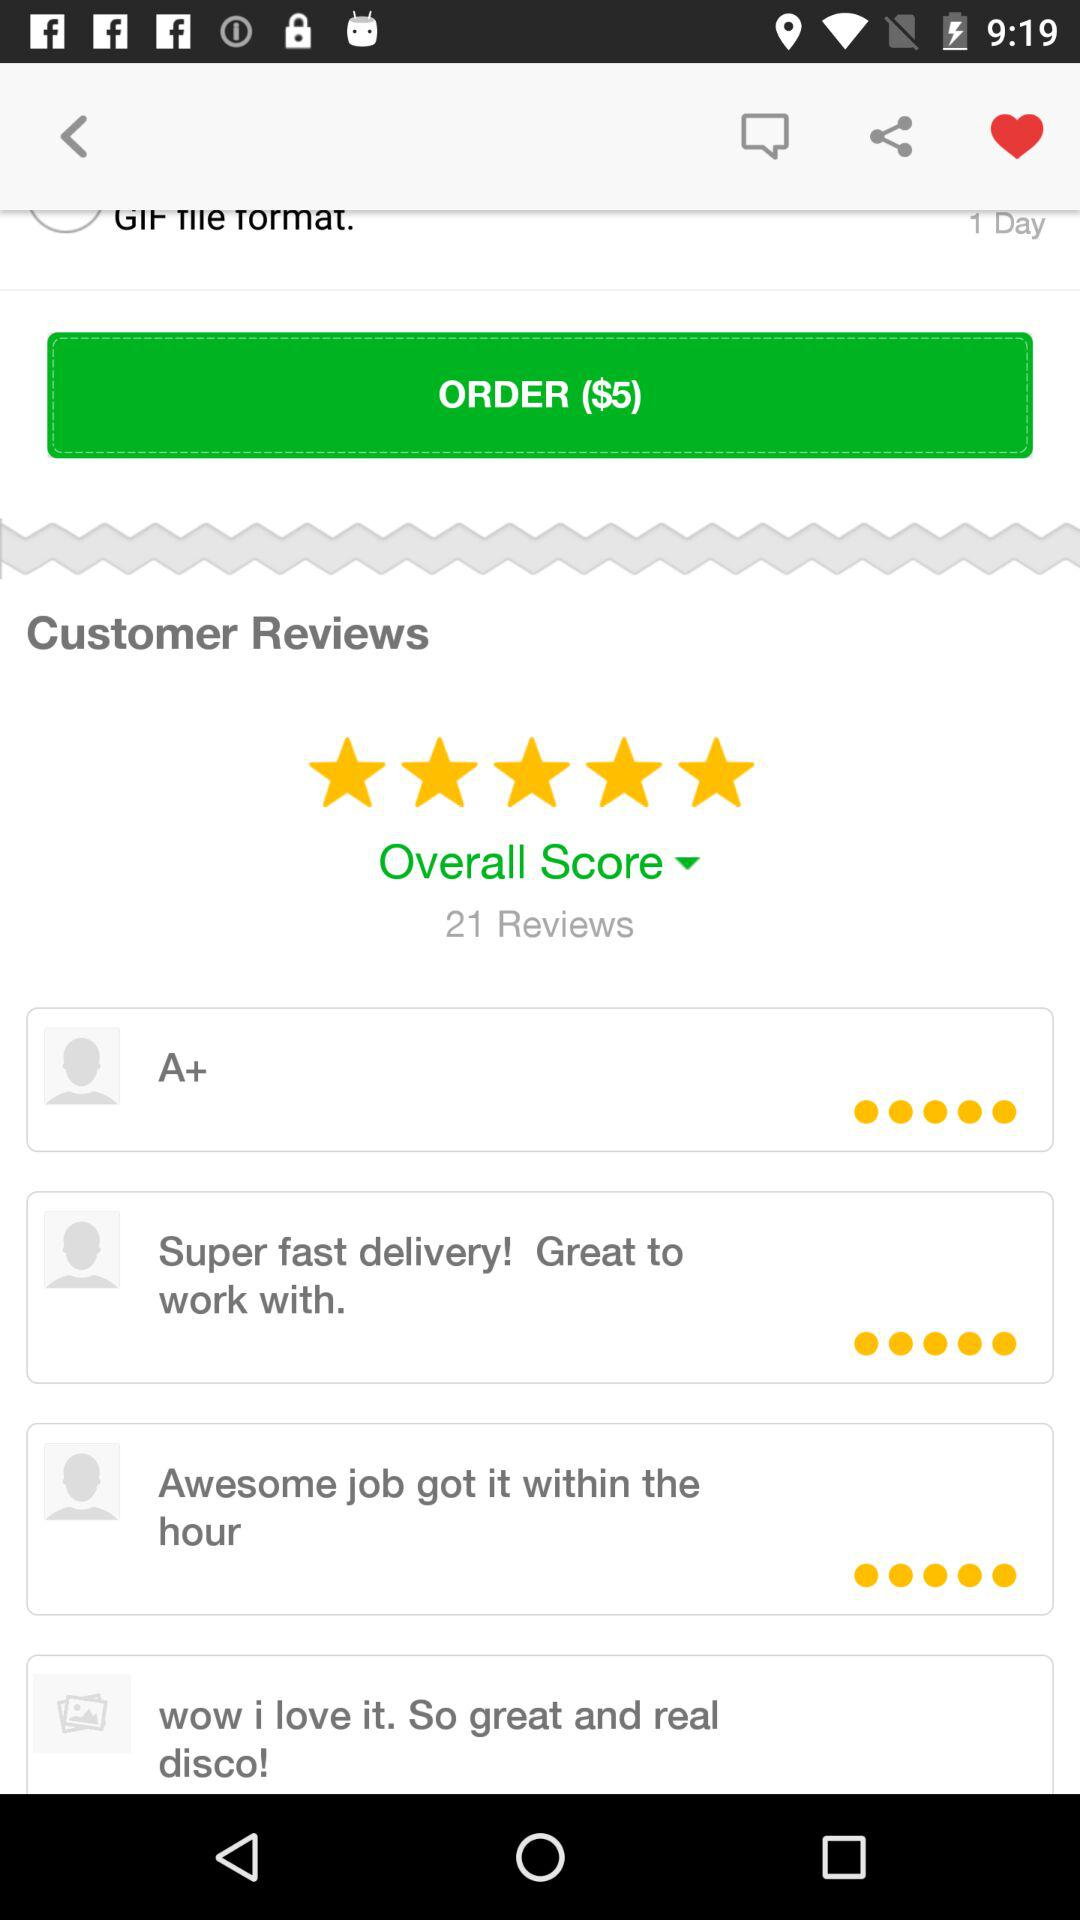How many reviews does the product have?
Answer the question using a single word or phrase. 21 